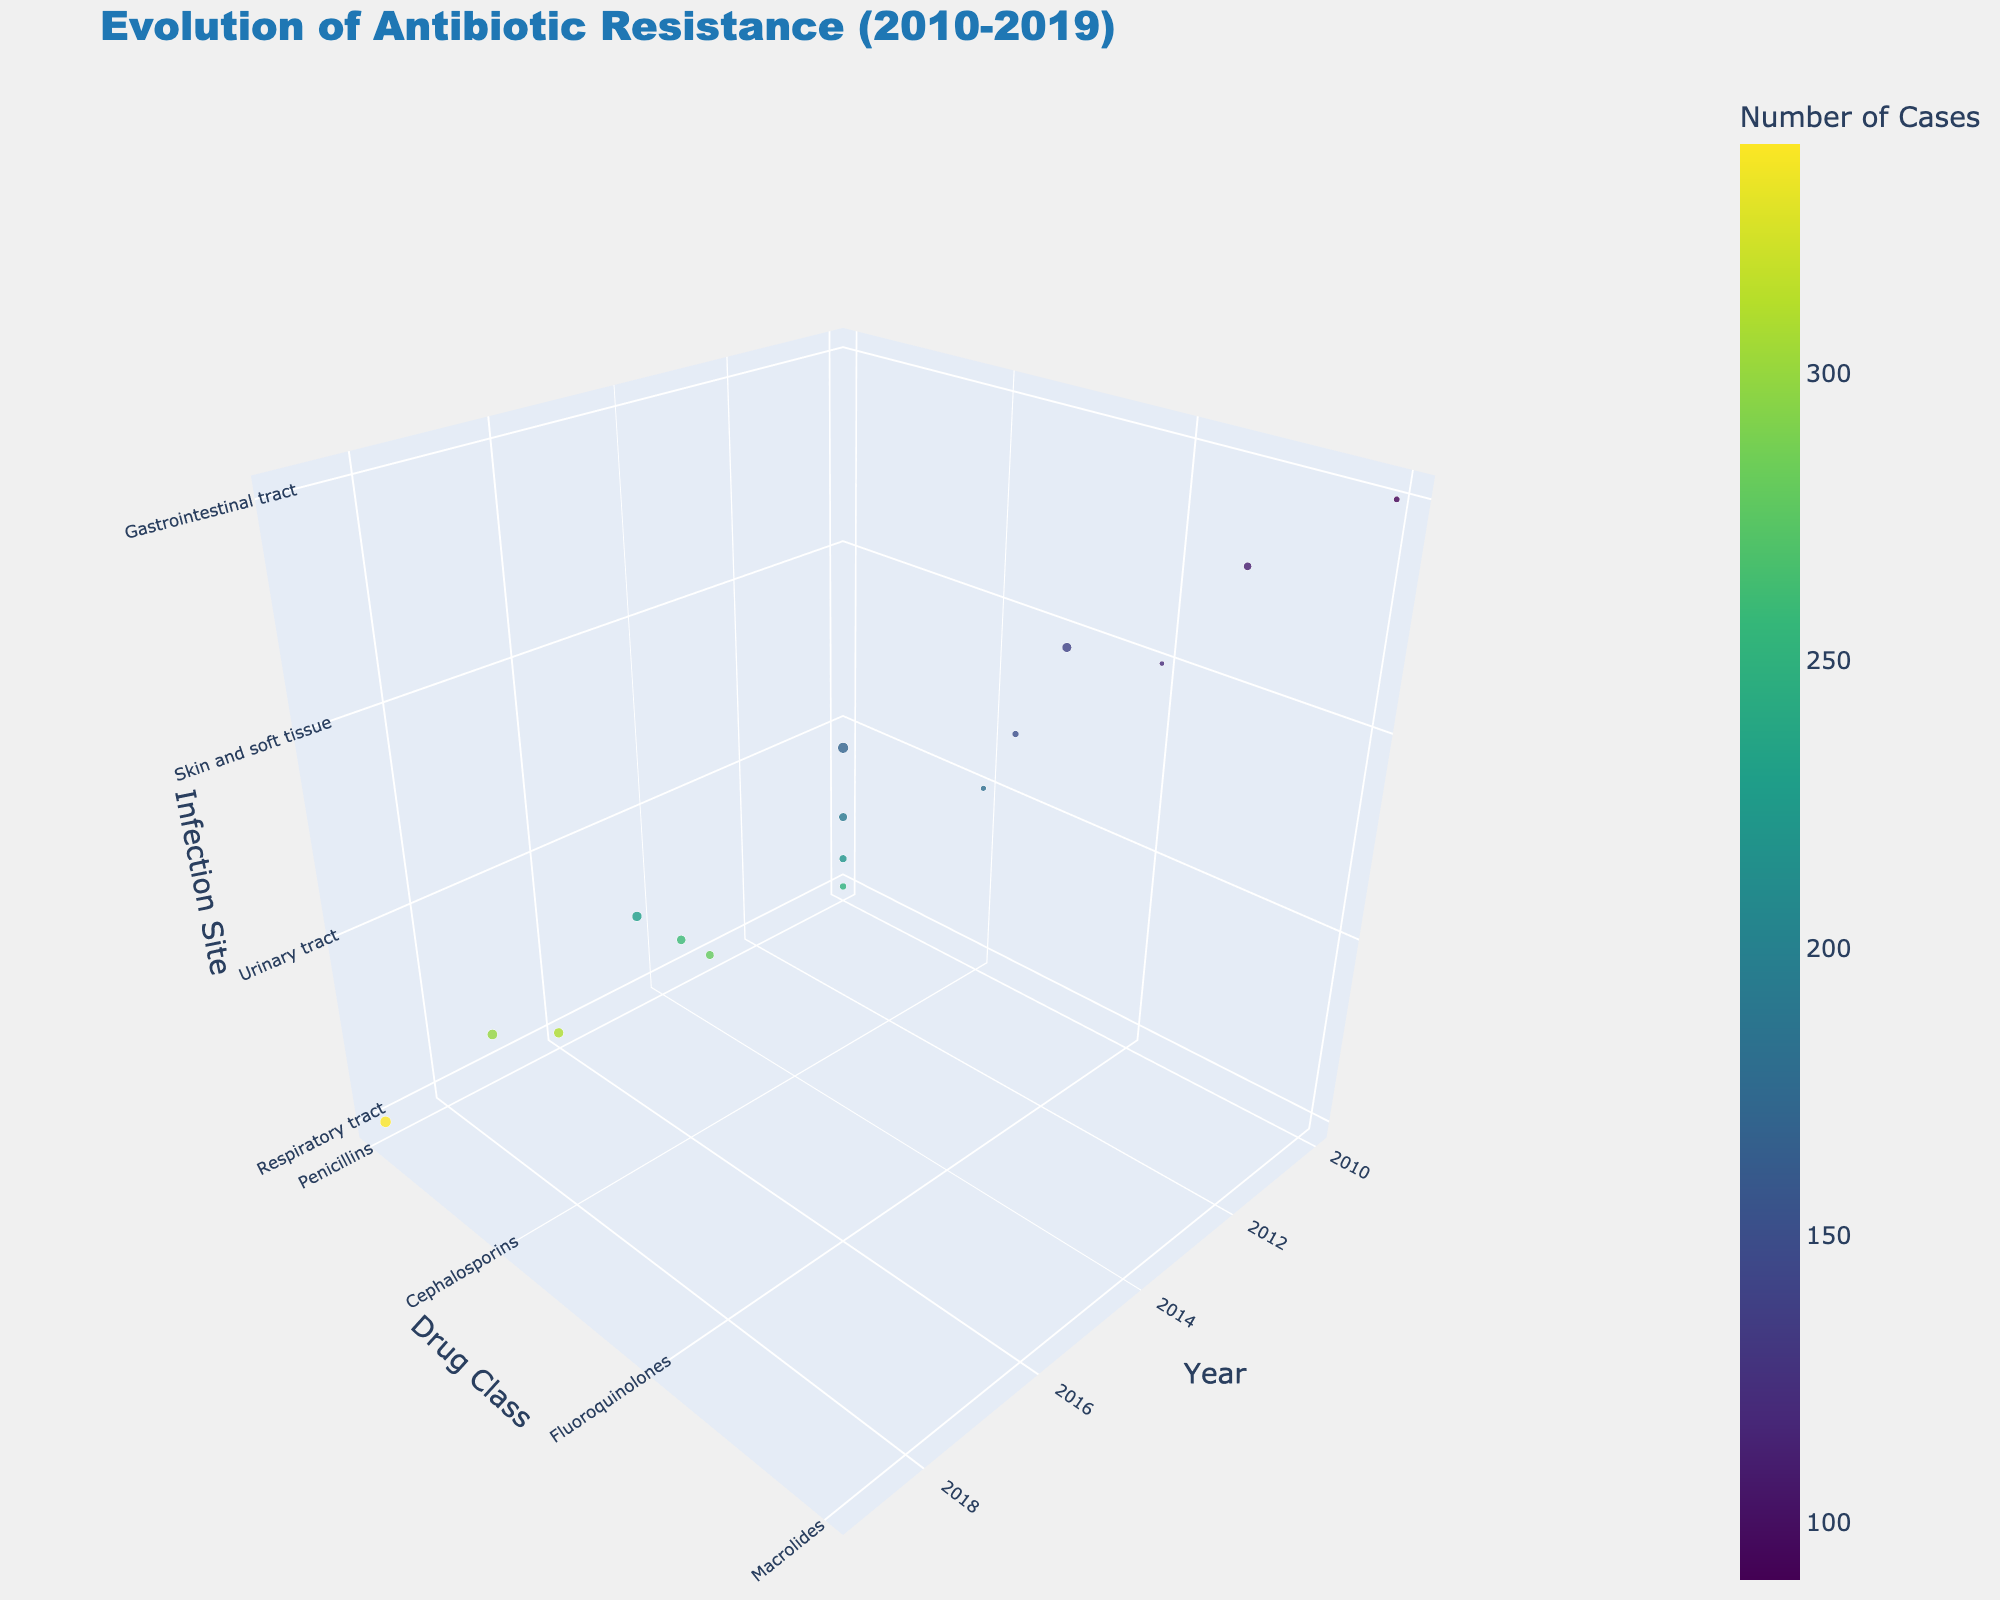What's the title of the chart? The title is usually displayed at the top of the figure. In this case, it reads as "Evolution of Antibiotic Resistance (2010-2019)"
Answer: Evolution of Antibiotic Resistance (2010-2019) What are the axes labeled as in the figure? The chart has three axes labeled as "Year," "Drug Class," and "Infection Site" respectively, which represent the evolution timeframe, the category of antibiotic drugs, and the site of bacterial infections
Answer: Year, Drug Class, Infection Site Which data point represents the highest percentage of resistance? By observing the bubble sizes, the largest bubble will indicate the highest percentage. The largest bubble is for Penicillins in the Respiratory tract in 2019 with 38% resistance
Answer: Penicillins in the Respiratory tract in 2019 How many cases were recorded for Cephalosporins in the Urinary tract in 2019? By hovering over the bubble corresponding to Cephalosporins in the Urinary Tract in 2019 and reading the tooltip, it is seen that the number of cases is 300
Answer: 300 What is the average resistance percentage for Macrolides across all years? Summing up resistance for Macrolides across the years (12+20+28+35) gives 95. Dividing by the number of years (4) gives the average resistance percentage as 23.75%
Answer: 23.75% Which Drug Class had the lowest resistance percentage in 2010 and what was the value? By scanning the bubble sizes for 2010, the smallest bubble is Fluoroquinolones in Skin and soft tissue with 8% resistance
Answer: Fluoroquinolones in Skin and soft tissue, 8% How has the number of cases for Fluoroquinolones in Skin and soft tissue changed from 2010 to 2019? The number of cases for Fluoroquinolones in Skin and soft tissue in 2010, 2013, 2016, and 2019 was 120, 150, 190, and 230 respectively. The change is from 120 to 230 which is a total increase of 110 cases
Answer: Increased by 110 cases Which year recorded the highest overall antibiotic resistance across all drug classes and infection sites? By comparing resistance percentages across all data points, the year 2019 shows the highest values more frequently (38%, 32%, 30%, 35%). This indicates 2019 recorded higher resistance on average
Answer: 2019 What has been the trend for Penicillins resistance in respiratory tract infections from 2010 to 2019? Observing the resistance percentages for Penicillins in the Respiratory tract over the years, the trend is increasing: 15% in 2010, 22% in 2013, 30% in 2016, and 38% in 2019
Answer: Increasing trend Which infection site exhibits the highest resistance percentage in 2016? By examining the resistance percentages for 2016, the highest recorded is for Penicillins in the Respiratory tract at 30%
Answer: Respiratory tract with Penicillins at 30% 